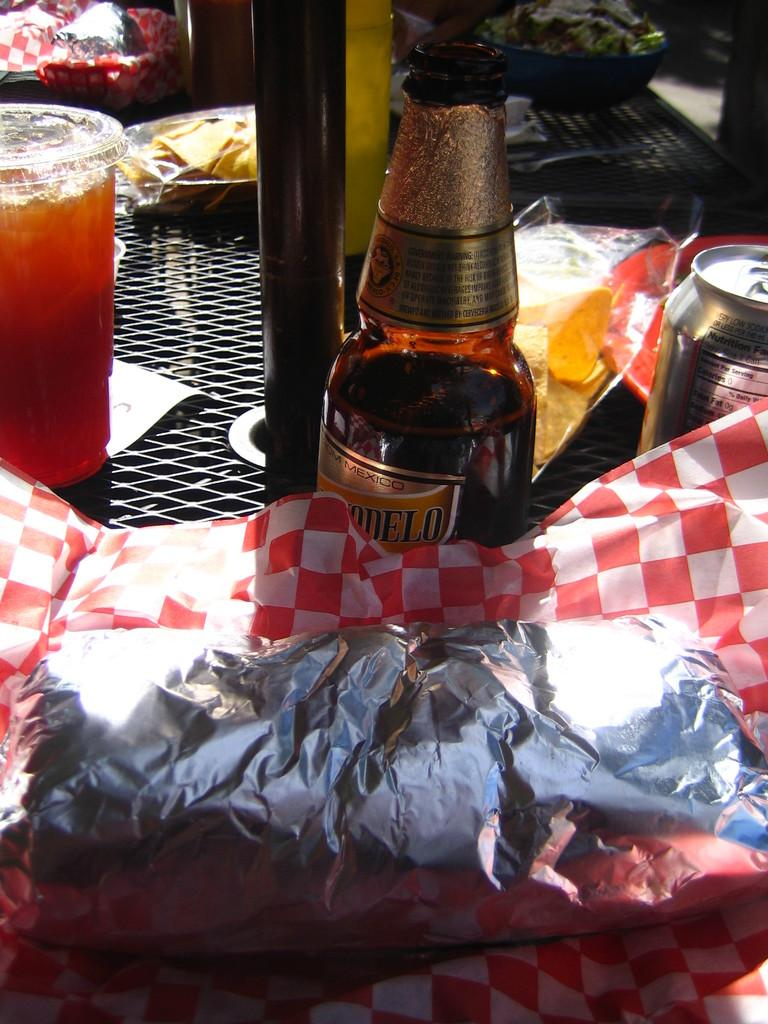What is in the bottle that is visible in the image? There is a bottle of cool drink in the image. Where is the bottle placed in the image? The bottle is placed on a table. What else can be seen on the table in the image? There is a glass at the left side of the image. How many fangs can be seen on the bottle in the image? There are no fangs present on the bottle in the image. What type of idea is being discussed in the image? There is no discussion or idea present in the image; it only features a bottle of cool drink and a glass on a table. 